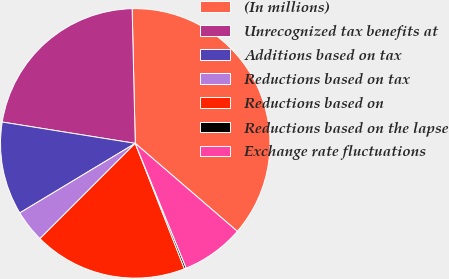<chart> <loc_0><loc_0><loc_500><loc_500><pie_chart><fcel>(In millions)<fcel>Unrecognized tax benefits at<fcel>Additions based on tax<fcel>Reductions based on tax<fcel>Reductions based on<fcel>Reductions based on the lapse<fcel>Exchange rate fluctuations<nl><fcel>36.69%<fcel>22.1%<fcel>11.16%<fcel>3.87%<fcel>18.45%<fcel>0.22%<fcel>7.51%<nl></chart> 